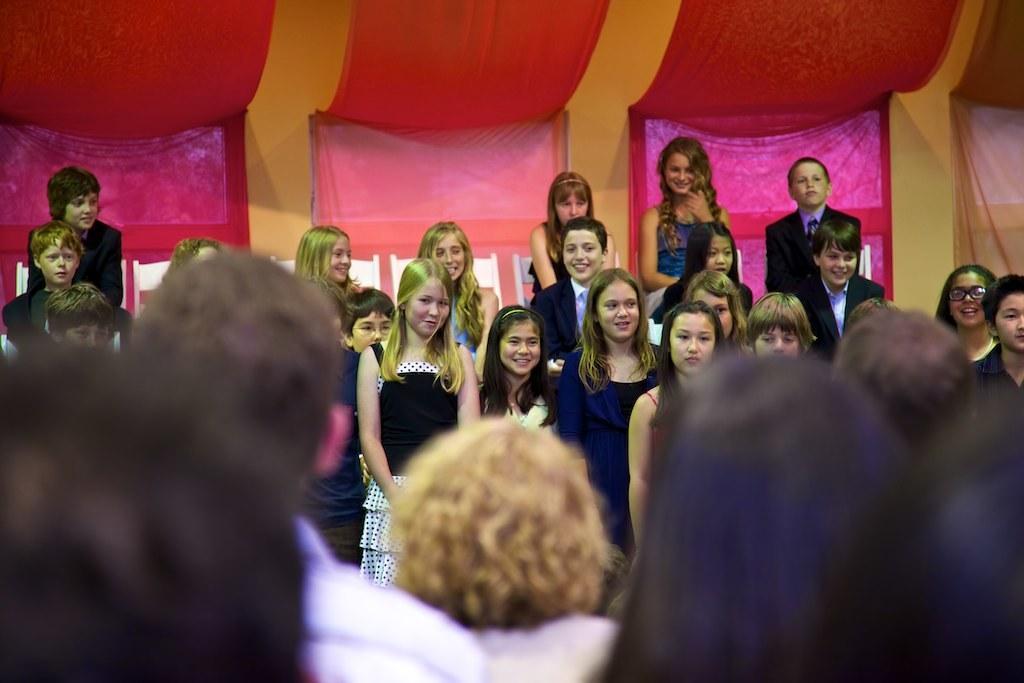Could you give a brief overview of what you see in this image? In the image we can see there are many people standing, they are wearing clothes and they are smiling. This is a decorative cloth and this part of the image is blurred. 